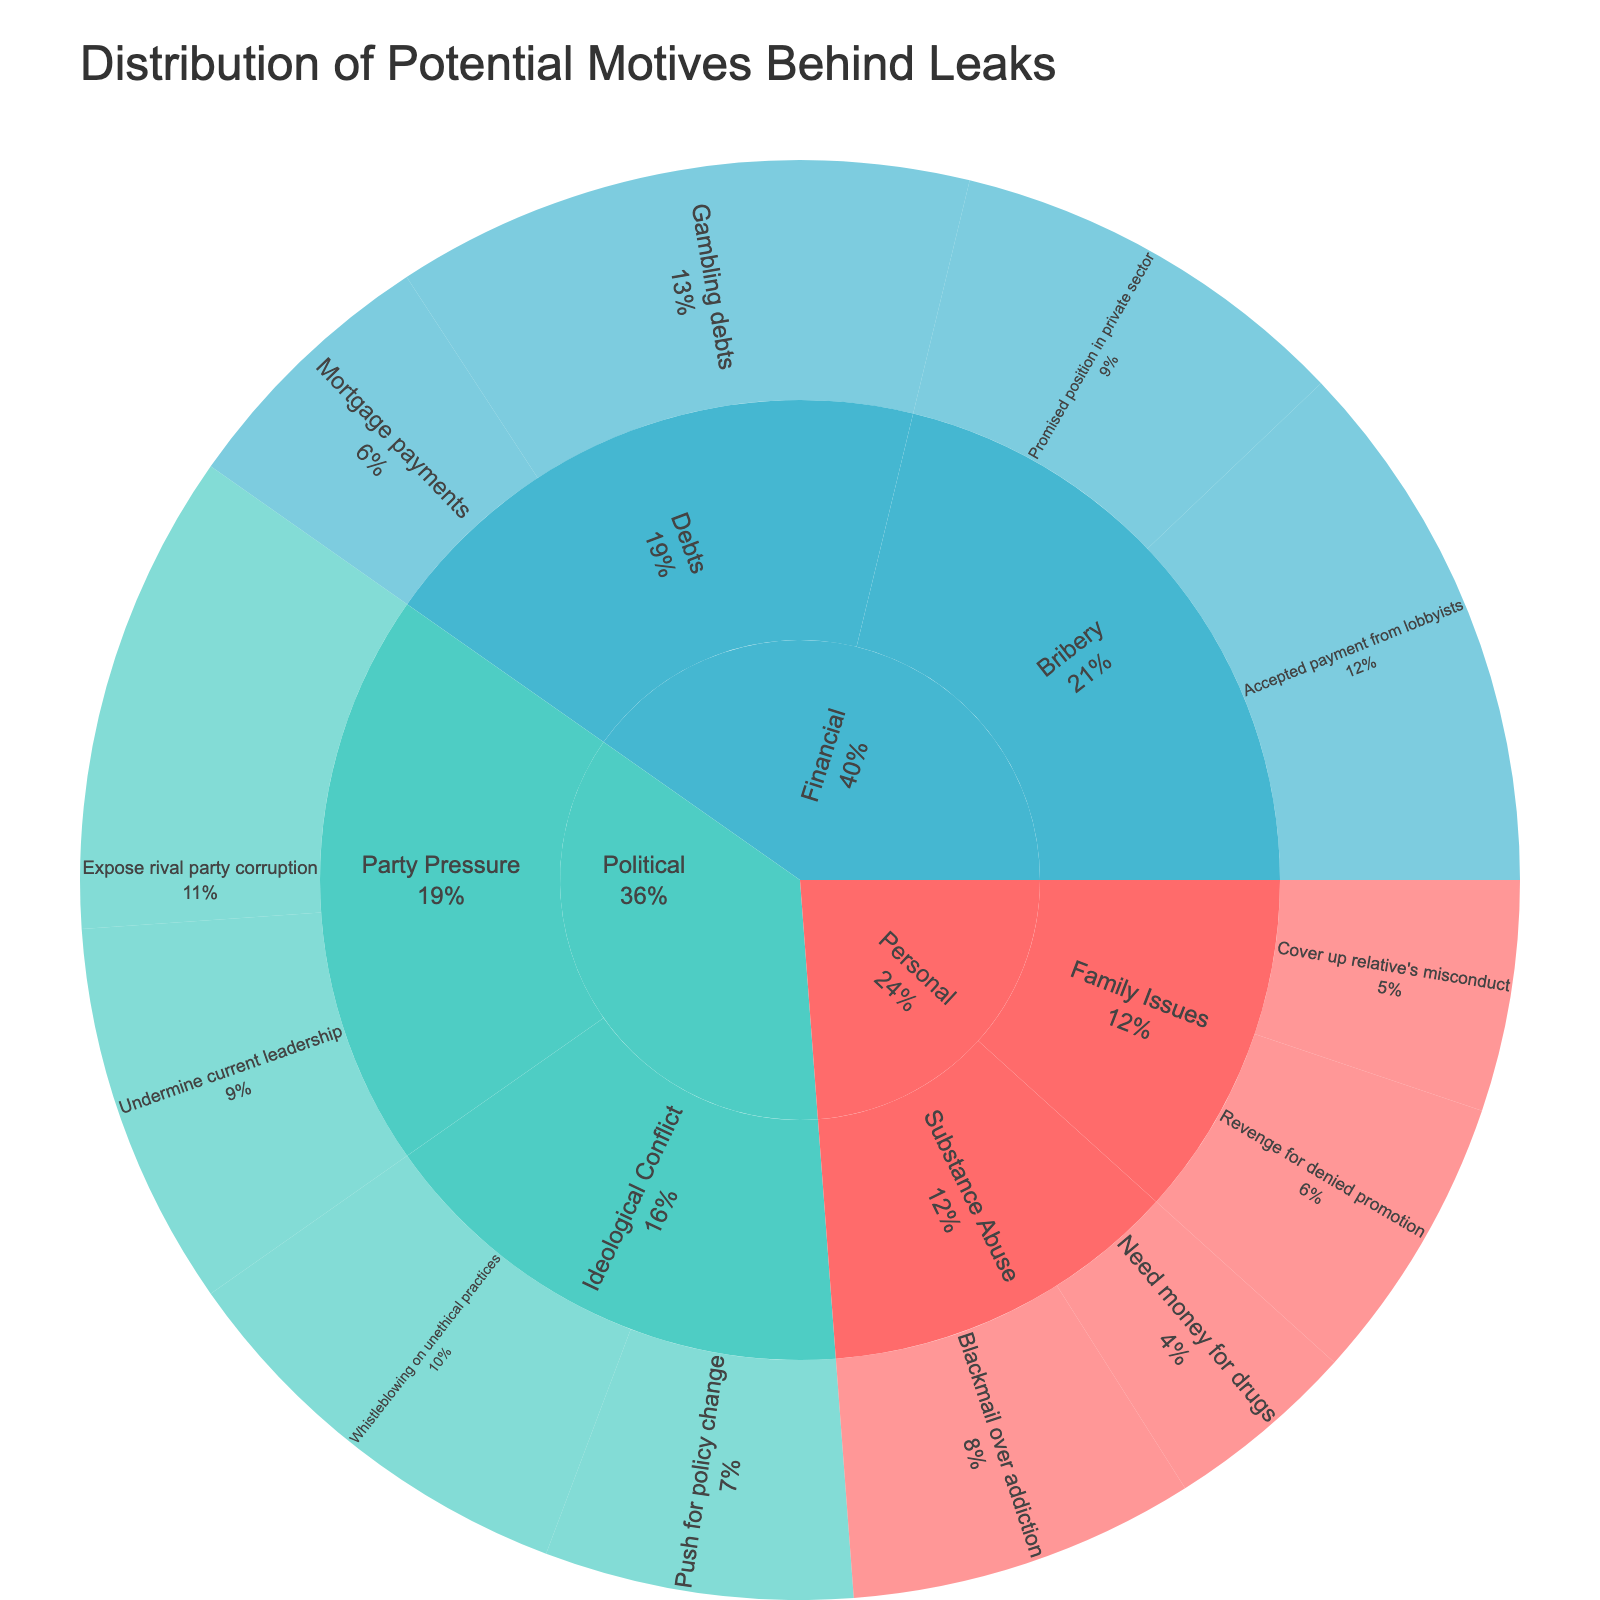What is the title of the figure? The title of the figure is typically placed at the top and indicates what the visual representation is about. Here, the title is placed boldly above the sunburst plot.
Answer: Distribution of Potential Motives Behind Leaks Which category has the highest overall value? To determine the category with the highest overall value, we need to sum up all the values within each category and compare the totals.
Answer: Financial How many motives are identified under the 'Personal' category? The 'Personal' category branches out into subcategories. Count all distinct motives listed under these subcategories.
Answer: 4 Which subcategory under 'Political' has the higher value when summed up? We need to sum the values of the motives under each subcategory within 'Political'. For 'Party Pressure', it’s 25 + 20 = 45, and for 'Ideological Conflict', it’s 22 + 16 = 38. Thus, 'Party Pressure' has the higher value.
Answer: Party Pressure What is the combined value of all the motives under the 'Debts' subcategory in the 'Financial' category? Add the values of the motives under 'Debts': 30 (Gambling debts) + 14 (Mortgage payments) = 44.
Answer: 44 Which motive has the largest single value and what is its value? By inspecting the values associated with each motive across all categories, we find that 'Gambling debts' has the value of 30, which is the highest.
Answer: Gambling debts, 30 Between the 'Political' and 'Personal' categories, which has more subcategories and by how many? Count the subcategories in each: Political has 2 ('Party Pressure' and 'Ideological Conflict'), Personal has 2 ('Family Issues' and 'Substance Abuse'). So they have an equal number of subcategories.
Answer: They are equal What percentage of the total value is attributed to 'Accepted payment from lobbyists' under 'Financial'? First, calculate the total of all values. Then take the value of 'Accepted payment from lobbyists' (28) and divide by the total, multiplying by 100 to get the percentage. The organization of values needs summation: 15+12+18+10+25+20+22+16+30+14+28+21 = 231. Thus, (28/231) * 100 ≈ 12.12%.
Answer: ≈ 12.12% What is the difference in the total value between the 'Financial' category and the 'Political' category? Sum the values under each category: Financial (30 + 14 + 28 + 21 = 93) and Political (25 + 20 + 22 + 16 = 83). The difference is 93 - 83 = 10.
Answer: 10 Which motive under 'Substance Abuse' subcategory in 'Personal' has the higher value? Compare the values under 'Substance Abuse': 'Blackmail over addiction' (18) and 'Need money for drugs' (10). 'Blackmail over addiction' has the higher value.
Answer: Blackmail over addiction 